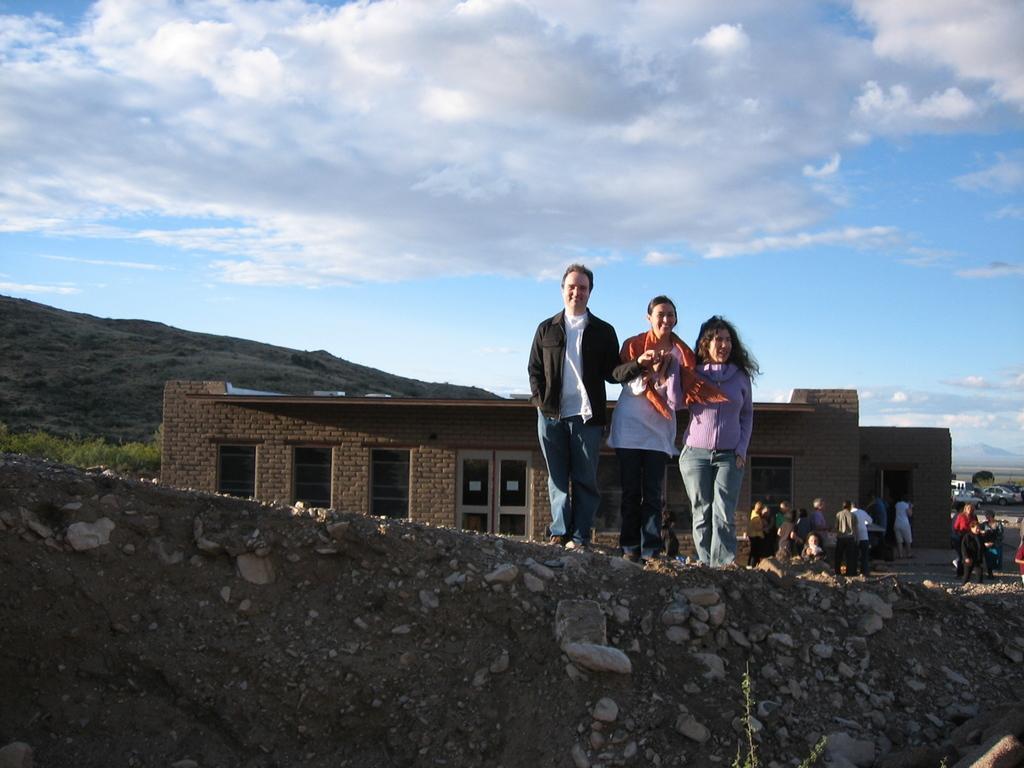Please provide a concise description of this image. On the right side, there are three persons in different color dresses, standing and smiling on the hill on which, there are stones. In the background, there are persons, there are buildings, there is a mountain and there are clouds in the blue sky. 